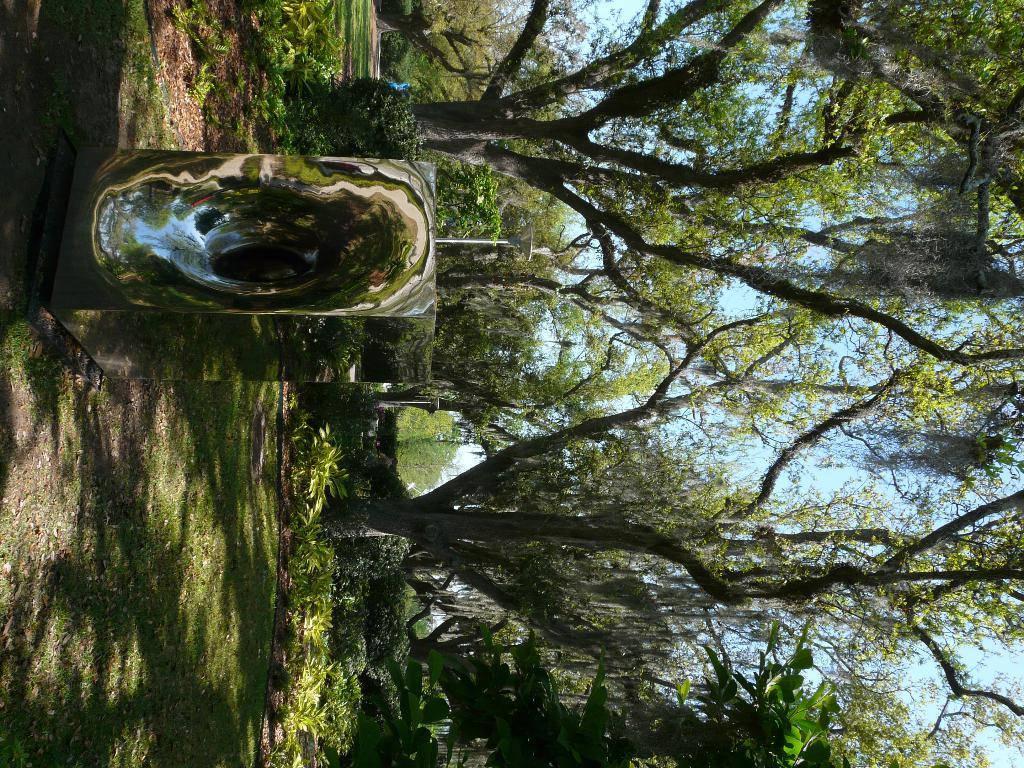What type of vegetation can be seen in the image? There are plants and trees in the image. Can you describe the sky in the image? The sky is clear and visible in the background of the image. What type of breakfast is being served in the image? There is no breakfast or any food visible in the image; it features plants, trees, and a clear sky. What color is the vest worn by the person in the image? There is no person or vest present in the image. 